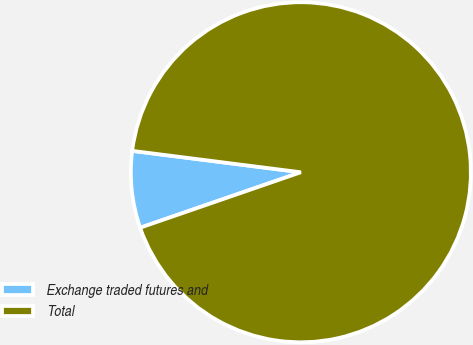<chart> <loc_0><loc_0><loc_500><loc_500><pie_chart><fcel>Exchange traded futures and<fcel>Total<nl><fcel>7.3%<fcel>92.7%<nl></chart> 